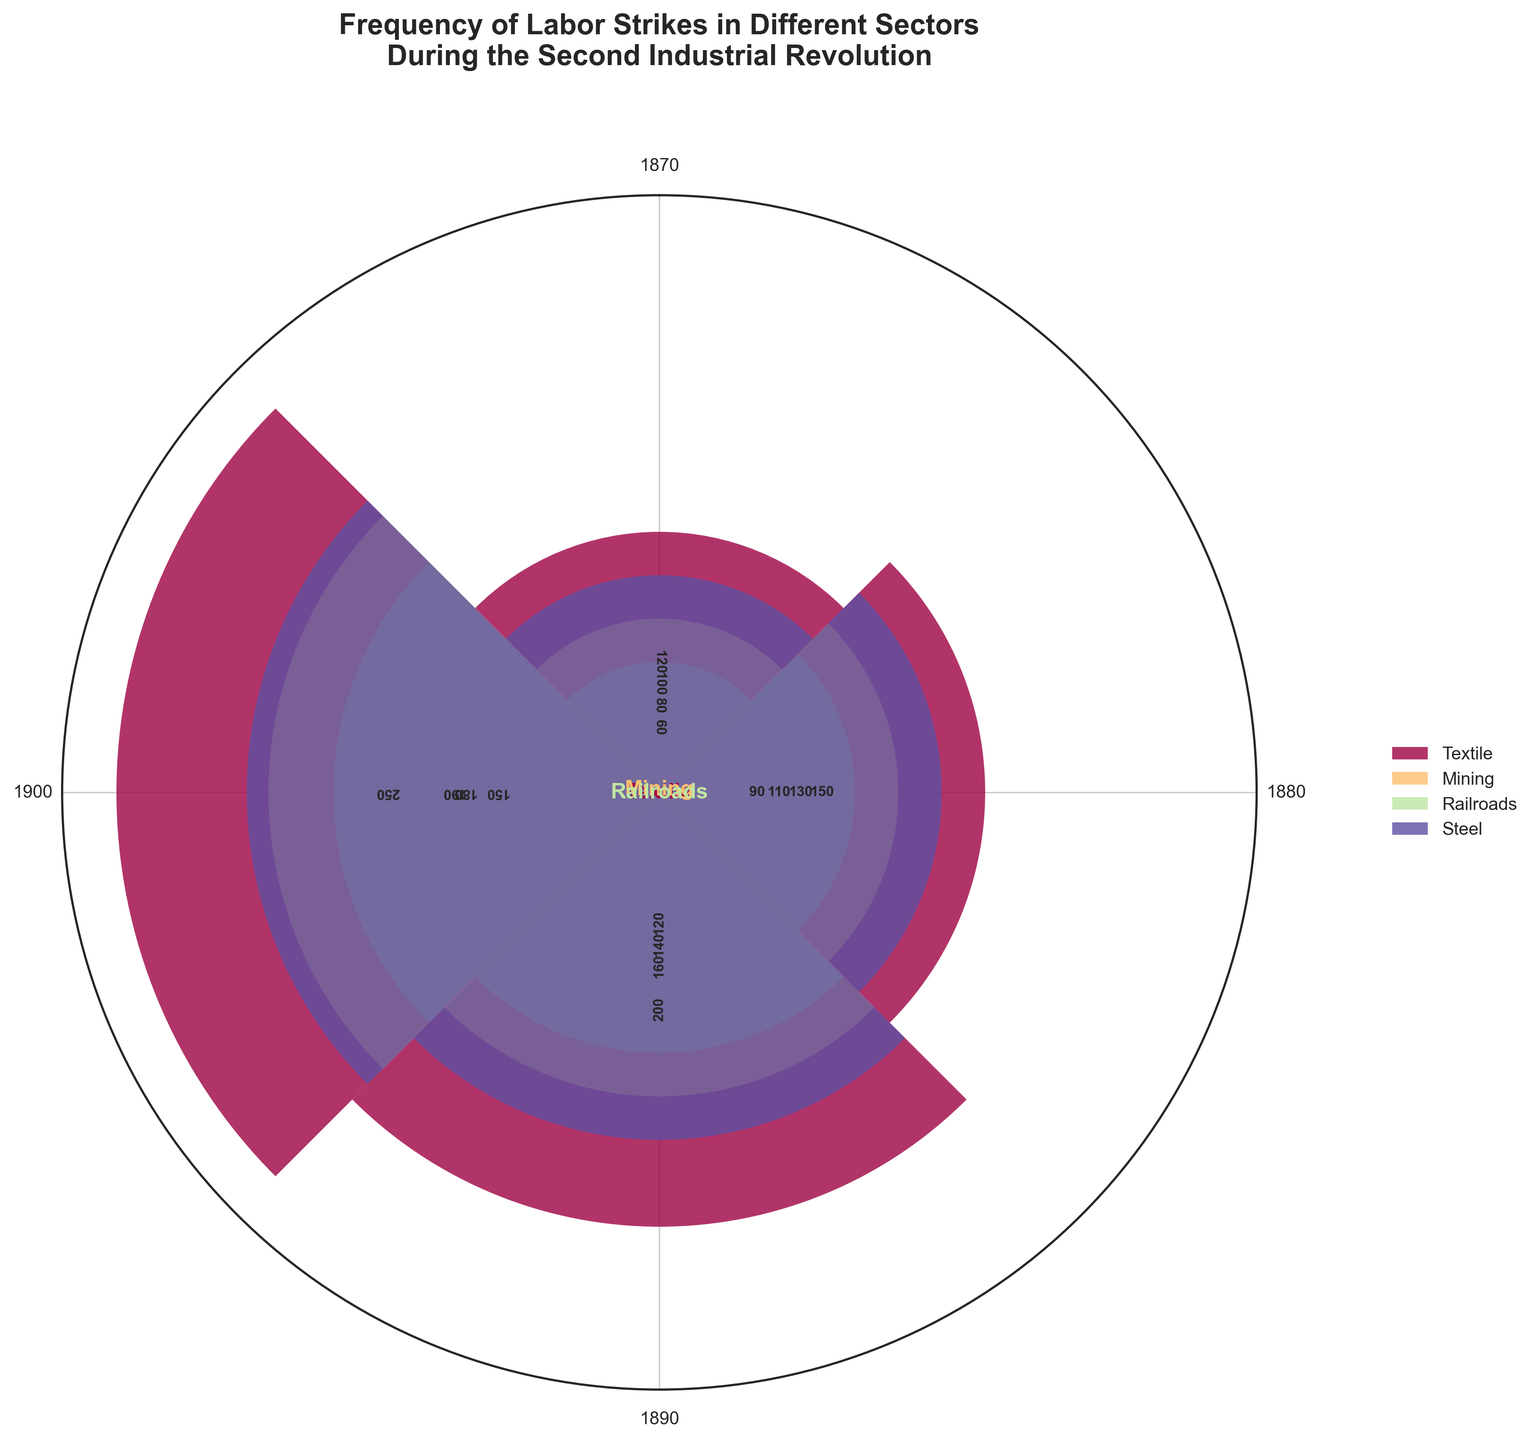1. What's the title of the rose chart? The title of the chart is often positioned at the top and provides a brief explanation of the visualized data. In this chart, the title is "Frequency of Labor Strikes in Different Sectors During the Second Industrial Revolution".
Answer: Frequency of Labor Strikes in Different Sectors During the Second Industrial Revolution 2. Which sector experienced the highest frequency of labor strikes in 1900? To determine this, we need to compare the heights of the bars corresponding to the four sectors in 1900. The Textile sector has the tallest bar for 1900, indicating the highest frequency of labor strikes.
Answer: Textile 3. How did the frequency of labor strikes in the Mining sector change from 1870 to 1900? Observe the bars for Mining in the years 1870 and 1900. The frequency increased from 80 in 1870 to 180 in 1900. This is a positive difference of 100 strikes over the 30 years.
Answer: Increased by 100 4. In which year did the Steel sector see the highest frequency of labor strikes? Examine the bars corresponding to the Steel sector across all years. The tallest bar for Steel is in the year 1900, indicating the highest frequency of labor strikes.
Answer: 1900 5. How does the number of strikes in the Railroads sector in 1890 compare to that in 1880? Compare the heights of the bars for Railroads in the years 1880 and 1890. In 1880, the frequency was 90, and in 1890, it was 120. Therefore, the frequency in 1890 is higher than in 1880.
Answer: Higher in 1890 6. Which sector showed the most significant increase in labor strikes from 1880 to 1900? To find this, calculate the difference in frequency for each sector between 1880 and 1900: Textile (250-150 = 100), Mining (180-110 = 70), Railroads (150-90 = 60), and Steel (190-130 = 60). The Textile sector shows the largest increase.
Answer: Textile 7. What is the difference in the frequency of strikes between the Textile and Steel sectors in 1890? Find the bars for Textile and Steel for the year 1890. Textile had 200 strikes, and Steel had 160. The difference is 200 - 160 = 40.
Answer: 40 8. Which year had the lowest frequency of strikes across all sectors? Look for the year where the sum of the frequencies for all sectors is the lowest. Summing the frequencies: 1870 (360), 1880 (480), 1890 (620), and 1900 (770). The year 1870 has the lowest total frequency of strikes.
Answer: 1870 9. Arrange the sectors in descending order of labor strike frequency in 1900. Check the heights of the bars for the year 1900 for each sector: Textile (250), Steel (190), Mining (180), and Railroads (150). Sorting them yields: Textile, Steel, Mining, Railroads.
Answer: Textile, Steel, Mining, Railroads 10. What is the total number of labor strikes in the year 1880 across all sectors? Sum the frequencies of labor strikes for all sectors in 1880: Textile (150), Mining (110), Railroads (90), and Steel (130). The total is 150 + 110 + 90 + 130 = 480.
Answer: 480 